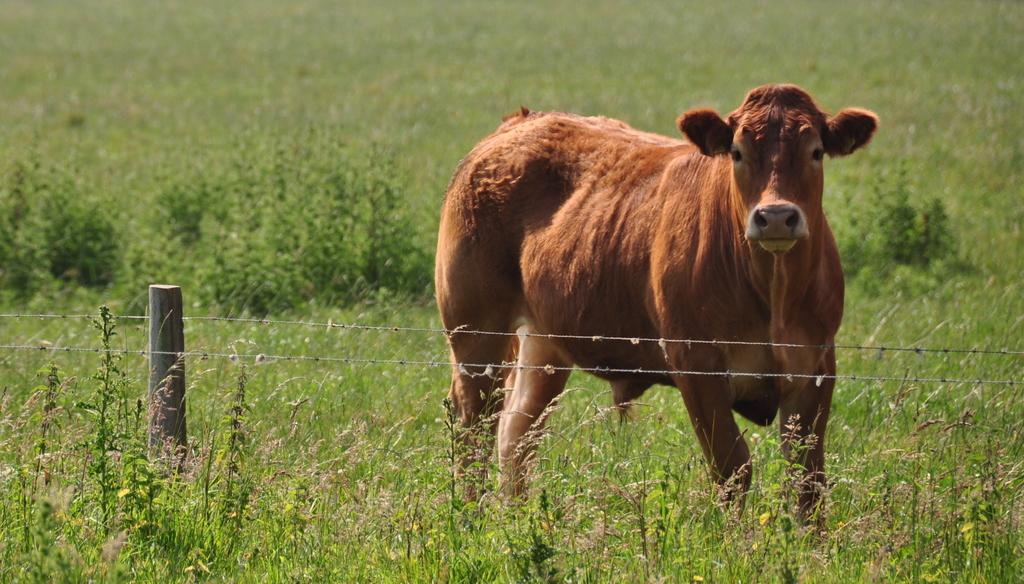What is the main subject in the center of the image? There is an animal in the center of the image. What can be seen in the background of the image? There is a fence in the image. What type of surface is visible in the image? The ground is visible in the image. What is the ground covered with? The ground is covered with grass. What type of skin condition does the queen have in the image? There is no queen present in the image, and therefore no skin condition can be observed. 